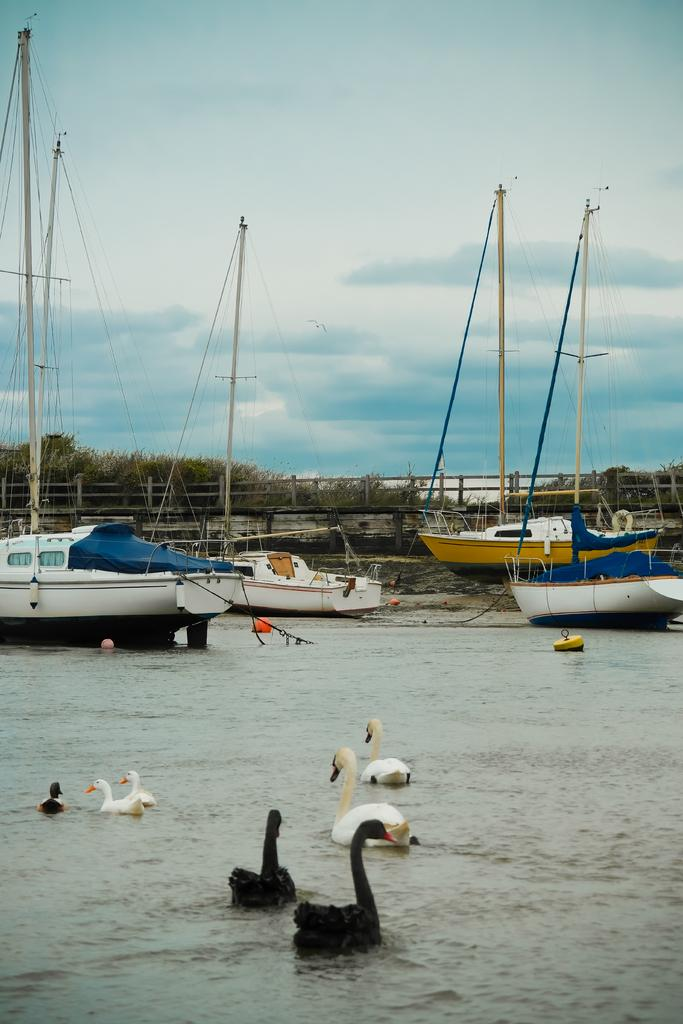What type of animals can be seen in the image? There are birds in the image. What is in the water in the image? There are ships in the water. What is the location of the ships in the background? There are ships on the ground in the background. What structures can be seen in the background? There are poles and a fence in the background. What else can be seen in the background? There are objects and trees in the background. What is visible in the sky in the background? There are clouds in the sky in the background. What type of hen is sitting on the roof of the house in the image? There is no hen or house present in the image. What substance is being used to paint the ships in the image? There is no indication of any substance being used to paint the ships in the image. 